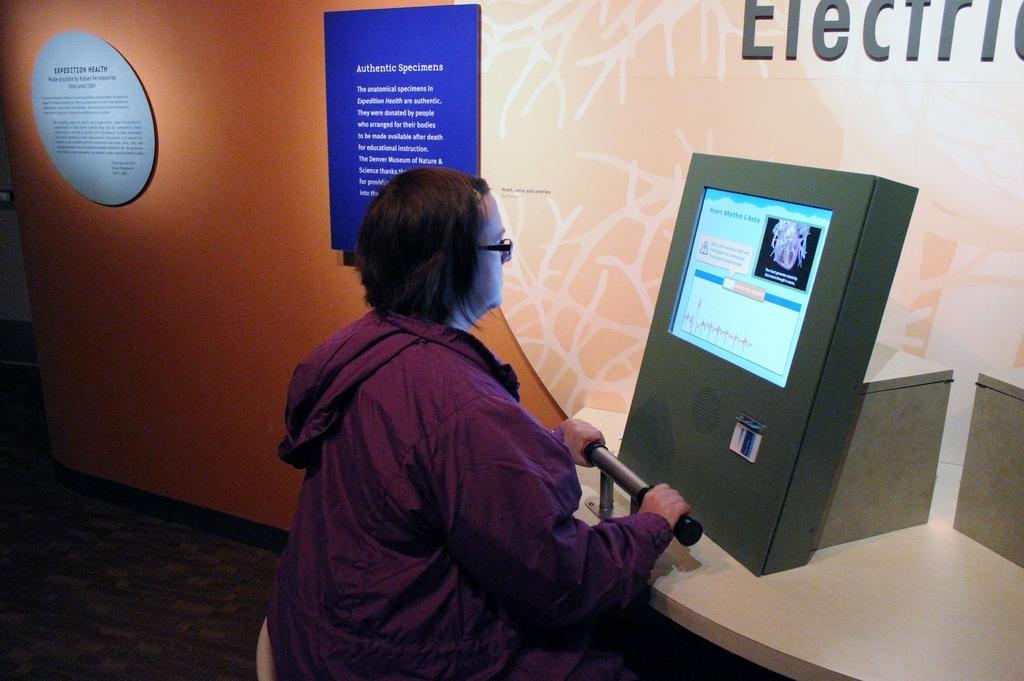Could you give a brief overview of what you see in this image? In this image we can see a person sitting on the chair in front of the display screen. In the background there are information boards to the wall. 